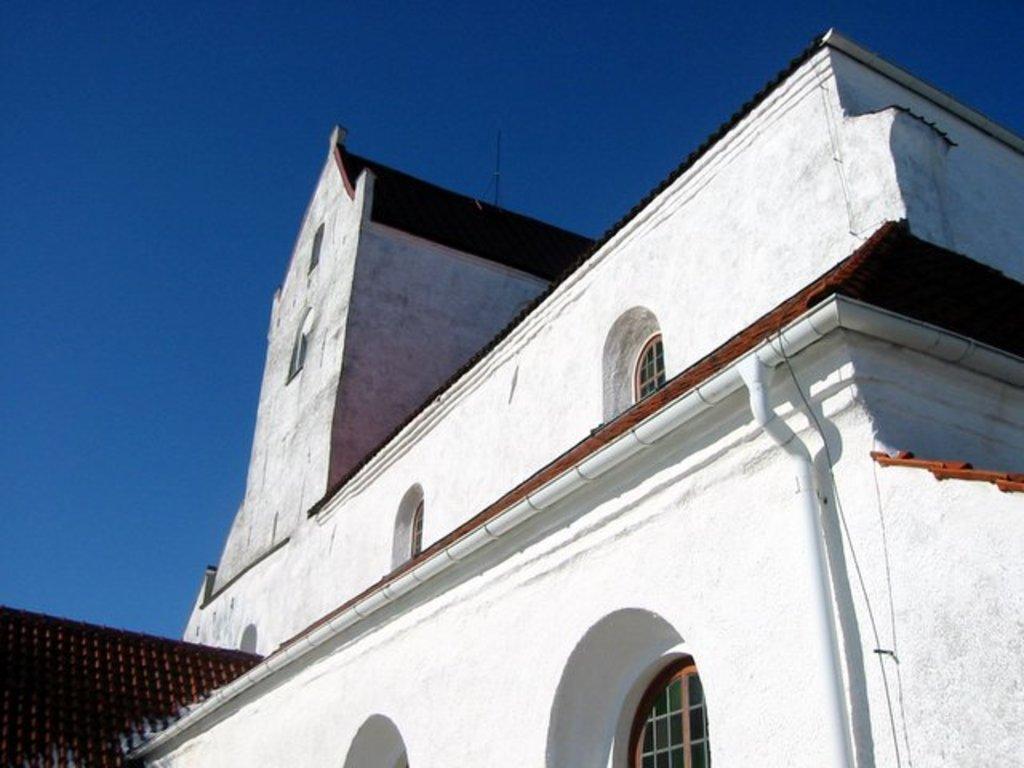In one or two sentences, can you explain what this image depicts? In this picture we can see a building. There are few arches on this building. Sky is blue in color. 